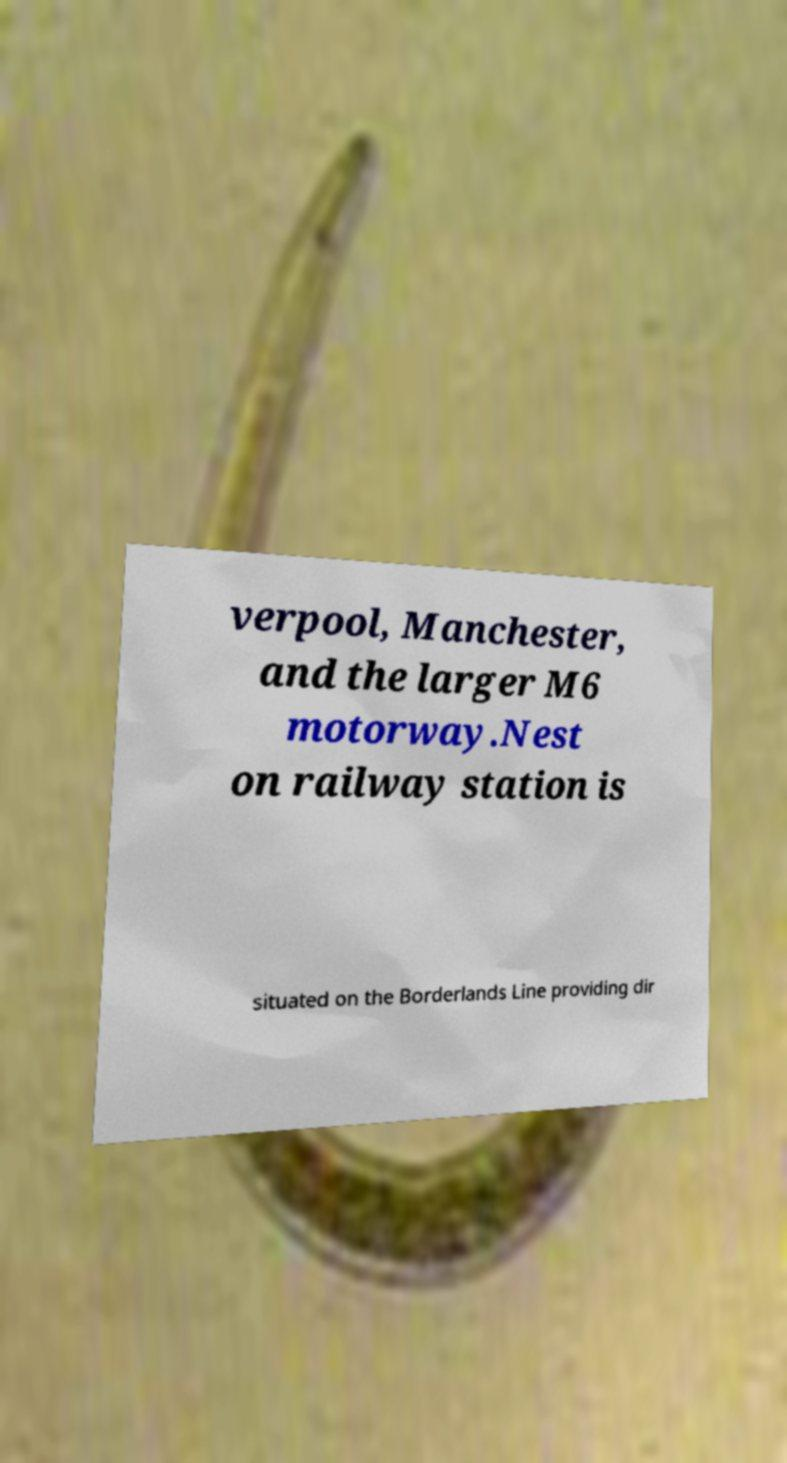Can you read and provide the text displayed in the image?This photo seems to have some interesting text. Can you extract and type it out for me? verpool, Manchester, and the larger M6 motorway.Nest on railway station is situated on the Borderlands Line providing dir 